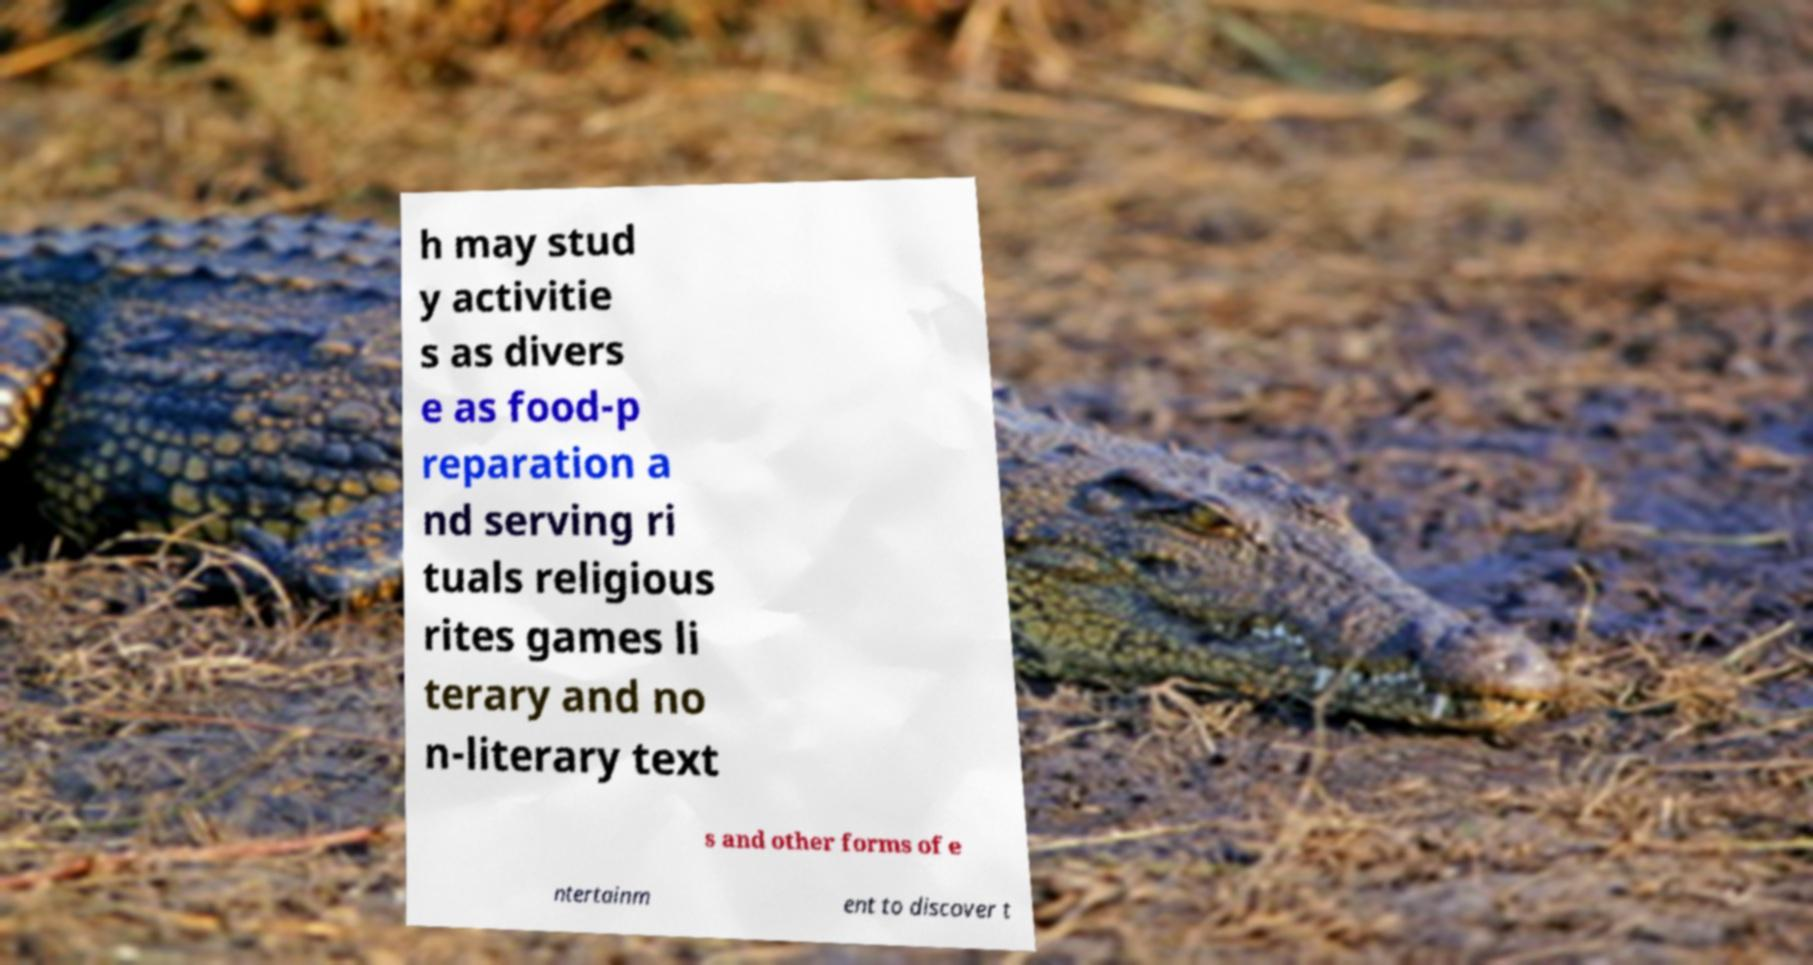Please identify and transcribe the text found in this image. h may stud y activitie s as divers e as food-p reparation a nd serving ri tuals religious rites games li terary and no n-literary text s and other forms of e ntertainm ent to discover t 